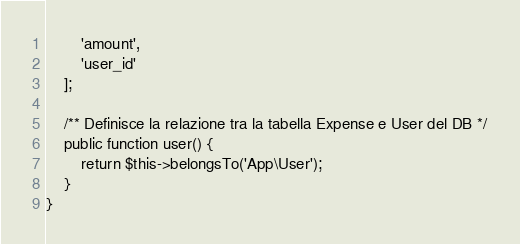Convert code to text. <code><loc_0><loc_0><loc_500><loc_500><_PHP_>        'amount',
        'user_id'
    ];

    /** Definisce la relazione tra la tabella Expense e User del DB */
    public function user() {
        return $this->belongsTo('App\User');
    }
}
</code> 